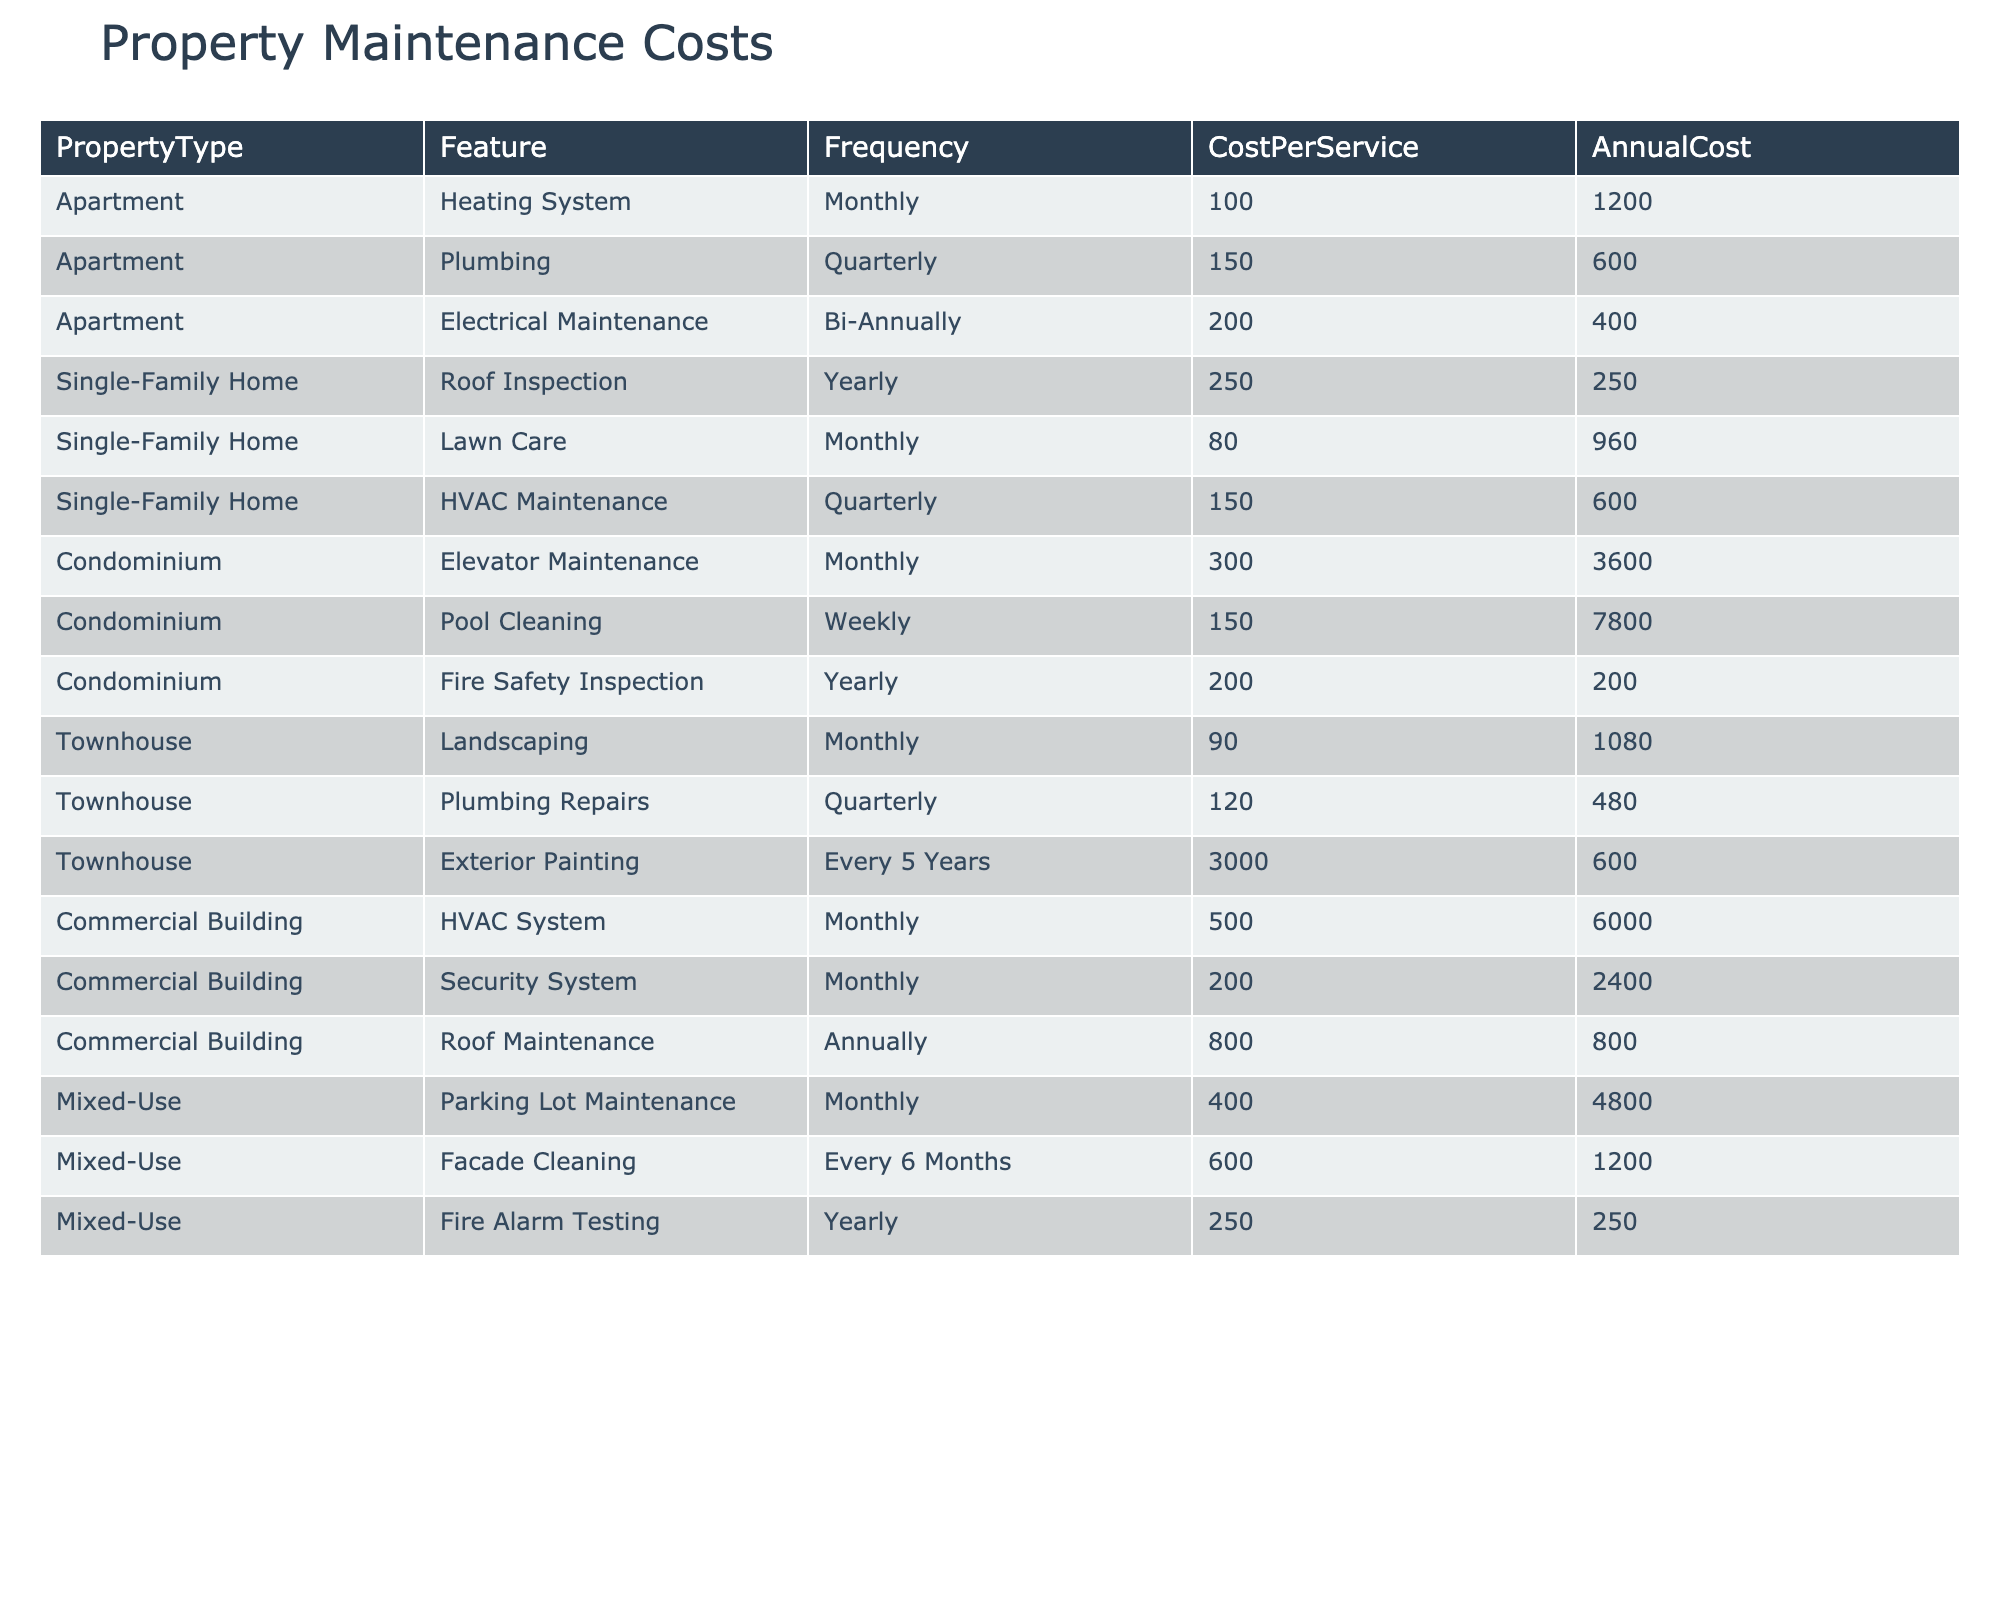What is the total annual cost for maintaining a condominium? To find the total annual cost for maintaining a condominium, sum the annual costs of its features: Elevator Maintenance (3600) + Pool Cleaning (7800) + Fire Safety Inspection (200) = 3600 + 7800 + 200 = 11600.
Answer: 11600 Which property feature in a single-family home is the least frequent service? The frequency of service for each feature in a single-family home is compared. Roof Inspection is yearly (1 time/year), Lawn Care is monthly (12 times/year), and HVAC Maintenance is quarterly (4 times/year). Yearly frequency is the least.
Answer: Roof Inspection What is the average cost per service for all property types? To find the average cost per service, sum all costs per service: 100 + 150 + 200 + 250 + 80 + 150 + 300 + 150 + 200 + 90 + 120 + 3000 + 500 + 200 + 800 + 400 + 600 + 250 = 6,192. There are 17 services, so the average is 6192/17 = 364.24.
Answer: 364.24 Does the townhouse have any services that are more frequent than quarterly? Checking the frequency of services in townhouses: Landscaping is monthly (12), Plumbing Repairs is quarterly (4), and Exterior Painting is every 5 years (0.2). Since Landscaping is monthly, it is more frequent than quarterly.
Answer: Yes What is the total annual maintenance cost for commercial buildings? To find the total, sum the annual costs: HVAC System (6000) + Security System (2400) + Roof Maintenance (800) = 6000 + 2400 + 800 = 9200.
Answer: 9200 Is the average annual cost for an apartment higher than that of a townhouse? Calculate the average for each: Apartment total is 1200 + 600 + 400 = 2200 for 3 services, average = 2200/3 = 733.33. Townhouse total is 1080 + 480 + 600 = 2160 for 3 services, average = 2160/3 = 720.33. Compare averages: 733.33 is higher than 720.33.
Answer: Yes What is the difference in the annual cost between landscaping in a townhouse and lawn care in a single-family home? The annual cost for Landscaping in a Townhouse is 1080, and for Lawn Care in a Single-Family Home, it is 960. The difference is 1080 - 960 = 120.
Answer: 120 Which property type has the highest annual maintenance cost? Analyzing total annual costs: Apartment total (2400), Single-Family Home total (1910), Condominium total (11600), Townhouse total (2160), Commercial Building total (9200), Mixed-Use total (6000). Condominium has the highest at 11600.
Answer: Condominium How often is fire alarm testing conducted in mixed-use properties? By examining the frequency for Fire Alarm Testing, it is categorized as a yearly service in mixed-use properties.
Answer: Yearly What is the cost difference between elevator maintenance and pool cleaning in a condominium? Elevator Maintenance costs 3600 per year and Pool Cleaning costs 7800 per year. The difference is 7800 - 3600 = 4200.
Answer: 4200 What is the total frequency of services for single-family homes in a year? Lawn Care is monthly (12), HVAC Maintenance is quarterly (4), and Roof Inspection is yearly (1). Summing these gives 12 + 4 + 1 = 17.
Answer: 17 